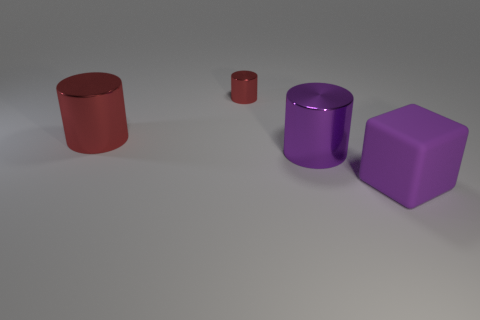How many other things are the same material as the block?
Provide a short and direct response. 0. How many shiny objects are large cylinders or small green blocks?
Give a very brief answer. 2. What color is the other small metallic object that is the same shape as the purple metal thing?
Keep it short and to the point. Red. What number of things are either red shiny things or purple cubes?
Make the answer very short. 3. What is the shape of the tiny thing that is the same material as the big red cylinder?
Keep it short and to the point. Cylinder. What number of small objects are red metal cylinders or purple objects?
Give a very brief answer. 1. How many other things are there of the same color as the tiny thing?
Your answer should be compact. 1. There is a large metal cylinder that is right of the big object to the left of the small red metal thing; how many shiny cylinders are behind it?
Your response must be concise. 2. There is a purple thing behind the rubber cube; is it the same size as the big rubber cube?
Keep it short and to the point. Yes. Are there fewer small red metal things that are in front of the big red thing than tiny objects that are right of the big cube?
Make the answer very short. No. 